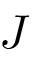<formula> <loc_0><loc_0><loc_500><loc_500>J</formula> 